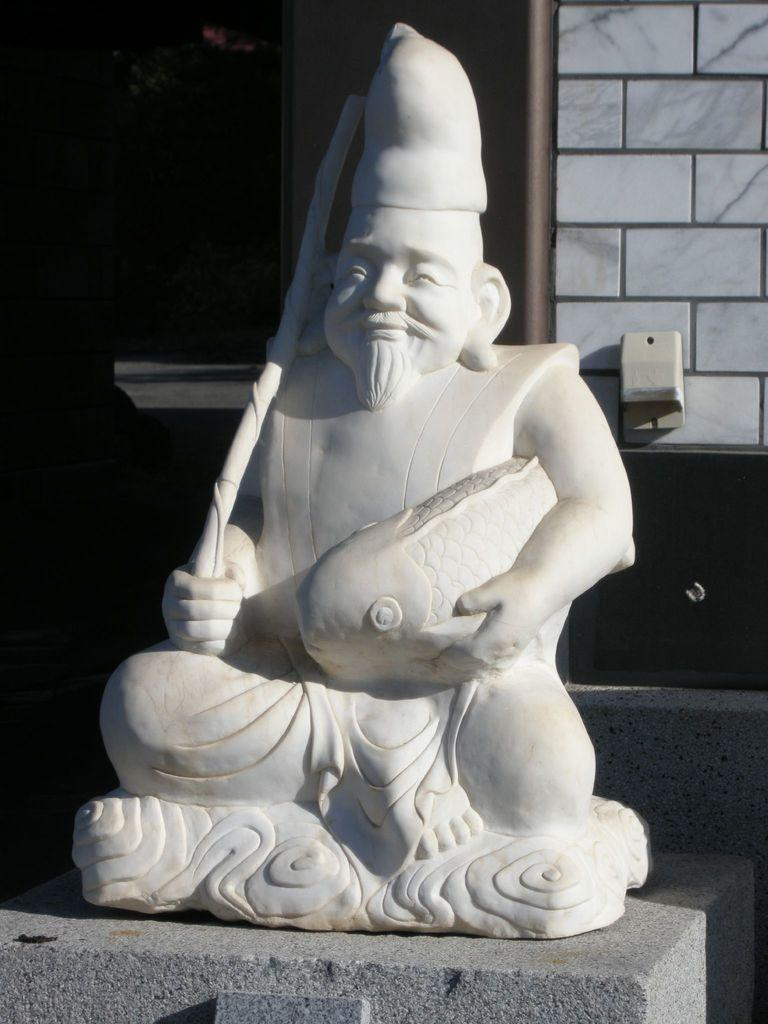What is the main subject in the center of the image? There is a statue in the center of the image. What can be seen in the background of the image? There is a wall and a board in the background of the image. How would you describe the lighting on the left side of the image? The left side of the image appears to be dark. How does the statue push the wall in the image? The statue does not push the wall in the image; it is a stationary object. 